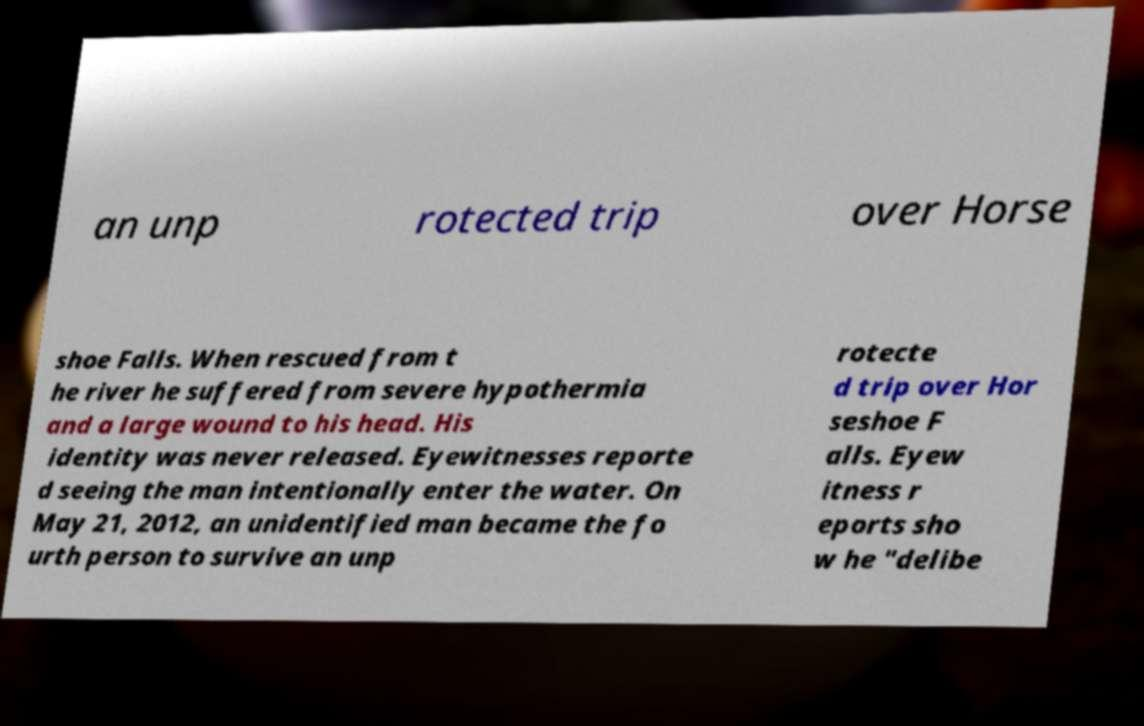There's text embedded in this image that I need extracted. Can you transcribe it verbatim? an unp rotected trip over Horse shoe Falls. When rescued from t he river he suffered from severe hypothermia and a large wound to his head. His identity was never released. Eyewitnesses reporte d seeing the man intentionally enter the water. On May 21, 2012, an unidentified man became the fo urth person to survive an unp rotecte d trip over Hor seshoe F alls. Eyew itness r eports sho w he "delibe 